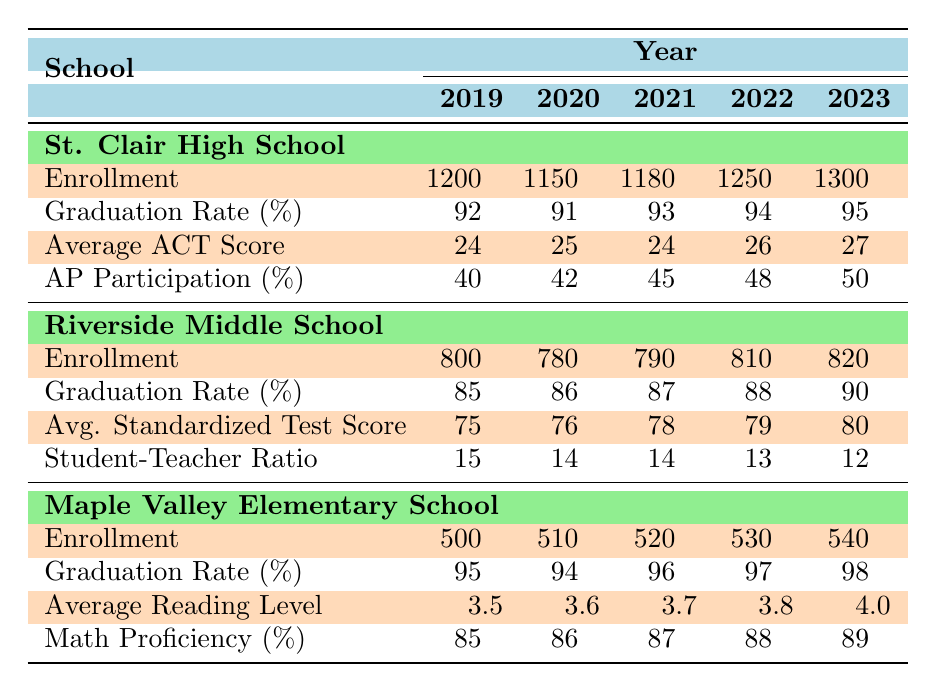What was the enrollment at St. Clair High School in 2022? From the table, we can find the specific value for enrollment at St. Clair High School in the year 2022 directly under the "Enrollment" row corresponding to 2022. The value is 1250.
Answer: 1250 In which year did Riverside Middle School have the highest graduation rate? By examining the "Graduation Rate (%)" row for Riverside Middle School, we can compare the rates for each year. The highest value is 90%, which occurs in 2023.
Answer: 2023 What is the average ACT score of St. Clair High School over the years? To find the average ACT score, we add the scores: (24 + 25 + 24 + 26 + 27) = 126. We then divide by the number of years (5) to get the average: 126/5 = 25.2.
Answer: 25.2 Is the graduation rate for Maple Valley Elementary School consistently above 90%? Looking at the "Graduation Rate (%)" row for Maple Valley Elementary School, the values are 95, 94, 96, 97, and 98 for the respective years. All values are greater than 90%.
Answer: Yes What was the difference in average standardized test scores for Riverside Middle School from 2019 to 2023? The average standardized test score in 2019 was 75, while in 2023 it was 80. To find the difference, we subtract 75 from 80: 80 - 75 = 5.
Answer: 5 Which school had the highest average reading level in 2023? In the table, we see that the "Average Reading Level" for Maple Valley Elementary School in 2023 is 4.0. This is the only reading level data present, so it’s the highest.
Answer: Maple Valley Elementary School How many students were enrolled in Riverside Middle School in 2021? The enrollment number for Riverside Middle School in 2021 is listed directly in the table under the "Enrollment" row for the year 2021, which is 790.
Answer: 790 What was the trend in AP participation for St. Clair High School from 2019 to 2023? By examining the "AP Participation (%)" row, we can see the participation rates for 2019 (40%), 2020 (42%), 2021 (45%), 2022 (48%), and 2023 (50%). The trend shows a consistent increase each year, indicating growth in AP participation.
Answer: Increasing Was the student-teacher ratio at Riverside Middle School lower in 2023 compared to 2019? The student-teacher ratio for Riverside Middle School in 2019 was 15, and in 2023 it was 12. Since 12 is less than 15, the ratio was indeed lower in 2023.
Answer: Yes 